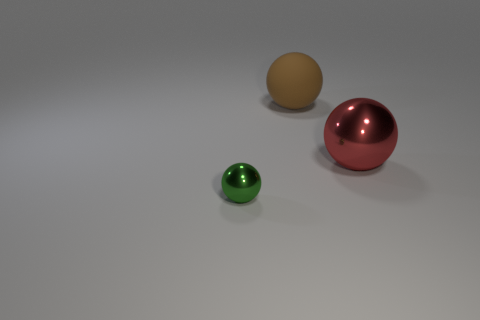Subtract all tiny balls. How many balls are left? 2 Add 1 green shiny objects. How many objects exist? 4 Subtract all big purple matte objects. Subtract all big objects. How many objects are left? 1 Add 2 large matte balls. How many large matte balls are left? 3 Add 3 brown rubber things. How many brown rubber things exist? 4 Subtract 0 purple balls. How many objects are left? 3 